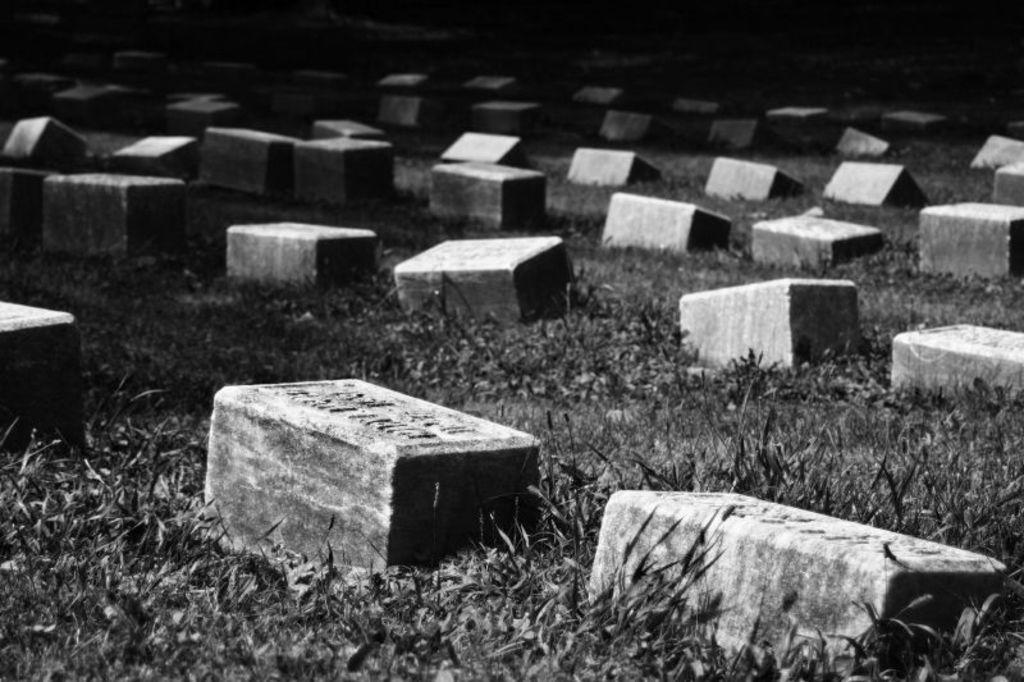What type of material is visible in the foreground of the image? There are bricks in the foreground of the image. Where are the bricks located? The bricks are on the grass. What type of vest can be seen in the image? There is no vest present in the image; it only features bricks on the grass. 